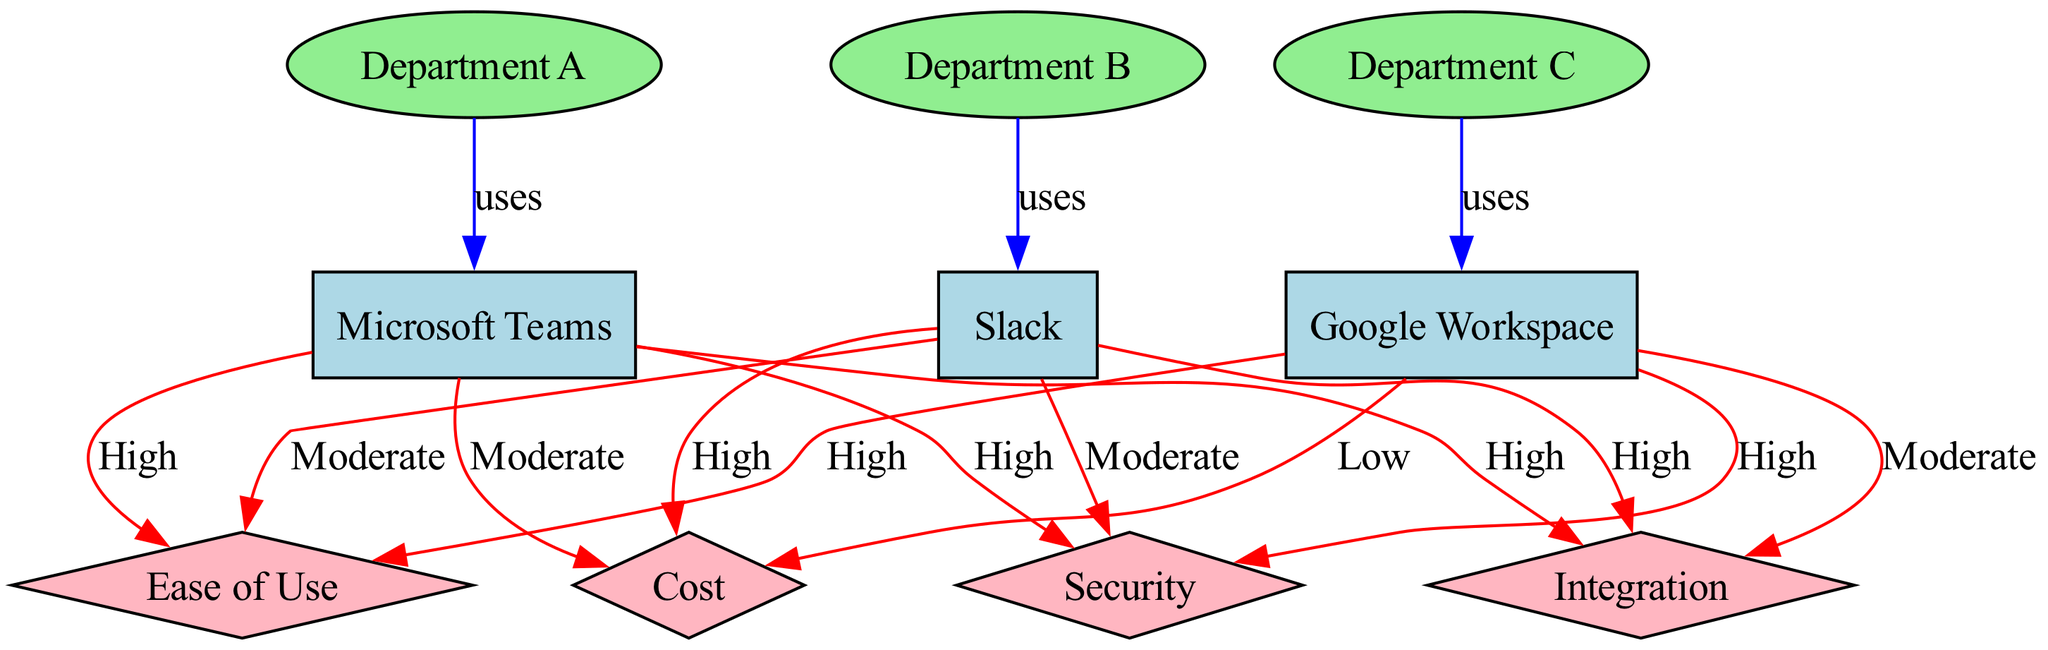What team collaboration tool is used by Department A? The diagram indicates that Department A has an edge labeled "uses" pointing to Microsoft Teams. Hence, Department A utilizes Microsoft Teams for collaboration.
Answer: Microsoft Teams Which department uses Slack? The edge from Department B to Slack, labeled "uses", shows that Department B is the department utilizing Slack as its collaboration tool.
Answer: Department B What is the ease of use rating for Google Workspace? The diagram shows that Google Workspace has an edge labeled "High" connecting it to the Ease of Use feature, indicating a high rating for this aspect.
Answer: High How many collaboration tools are represented in the diagram? By counting the nodes designed for collaboration tools, which are Microsoft Teams, Slack, and Google Workspace, we find a total of three tools.
Answer: 3 Which department has the lowest-rated cost among the collaboration tools? Analyzing the edges leads to the conclusion that Google Workspace has an edge labeled "Low" for Cost, which indicates it has the lowest cost rating compared to others.
Answer: Google Workspace Which collaboration tool has a high integration rating? Looking at the edges connected to integration, both Microsoft Teams and Slack have an edge labeled "High" indicating they both have high integration ratings.
Answer: Microsoft Teams and Slack What is the significance of the edges in the diagram? The edges connect departments to the tools they use and also indicate the ratings of various features for each tool, providing a comprehensive comparison of dependencies and attributes.
Answer: Connections between tools and departments Which collaboration tool has the highest security rating? The diagram provides data on security ratings where both Microsoft Teams and Google Workspace have edges labeled "High", indicating they are tied for the highest security rating.
Answer: Microsoft Teams and Google Workspace 